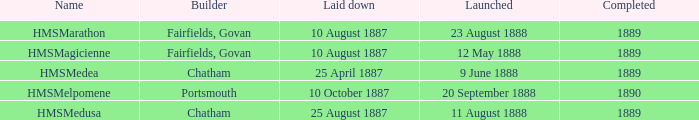Which builder completed before 1890 and launched on 9 june 1888? Chatham. 